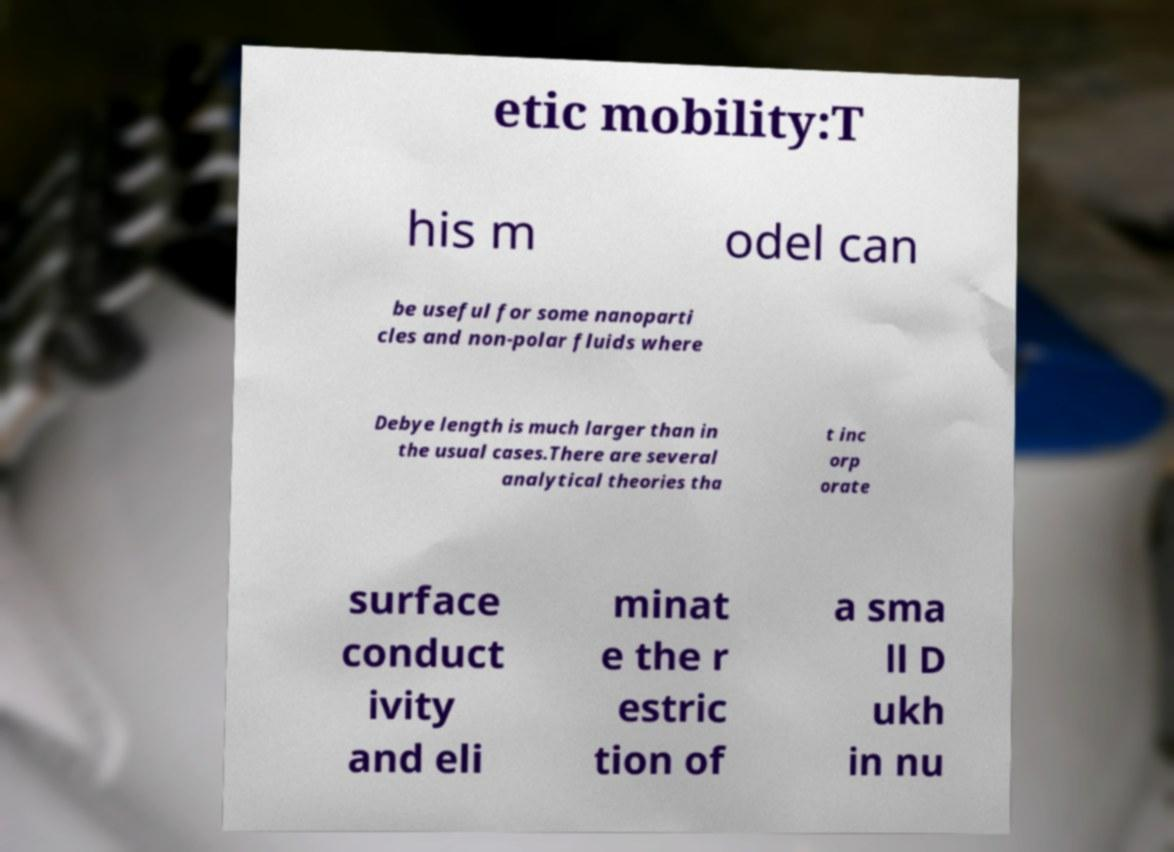Could you assist in decoding the text presented in this image and type it out clearly? etic mobility:T his m odel can be useful for some nanoparti cles and non-polar fluids where Debye length is much larger than in the usual cases.There are several analytical theories tha t inc orp orate surface conduct ivity and eli minat e the r estric tion of a sma ll D ukh in nu 